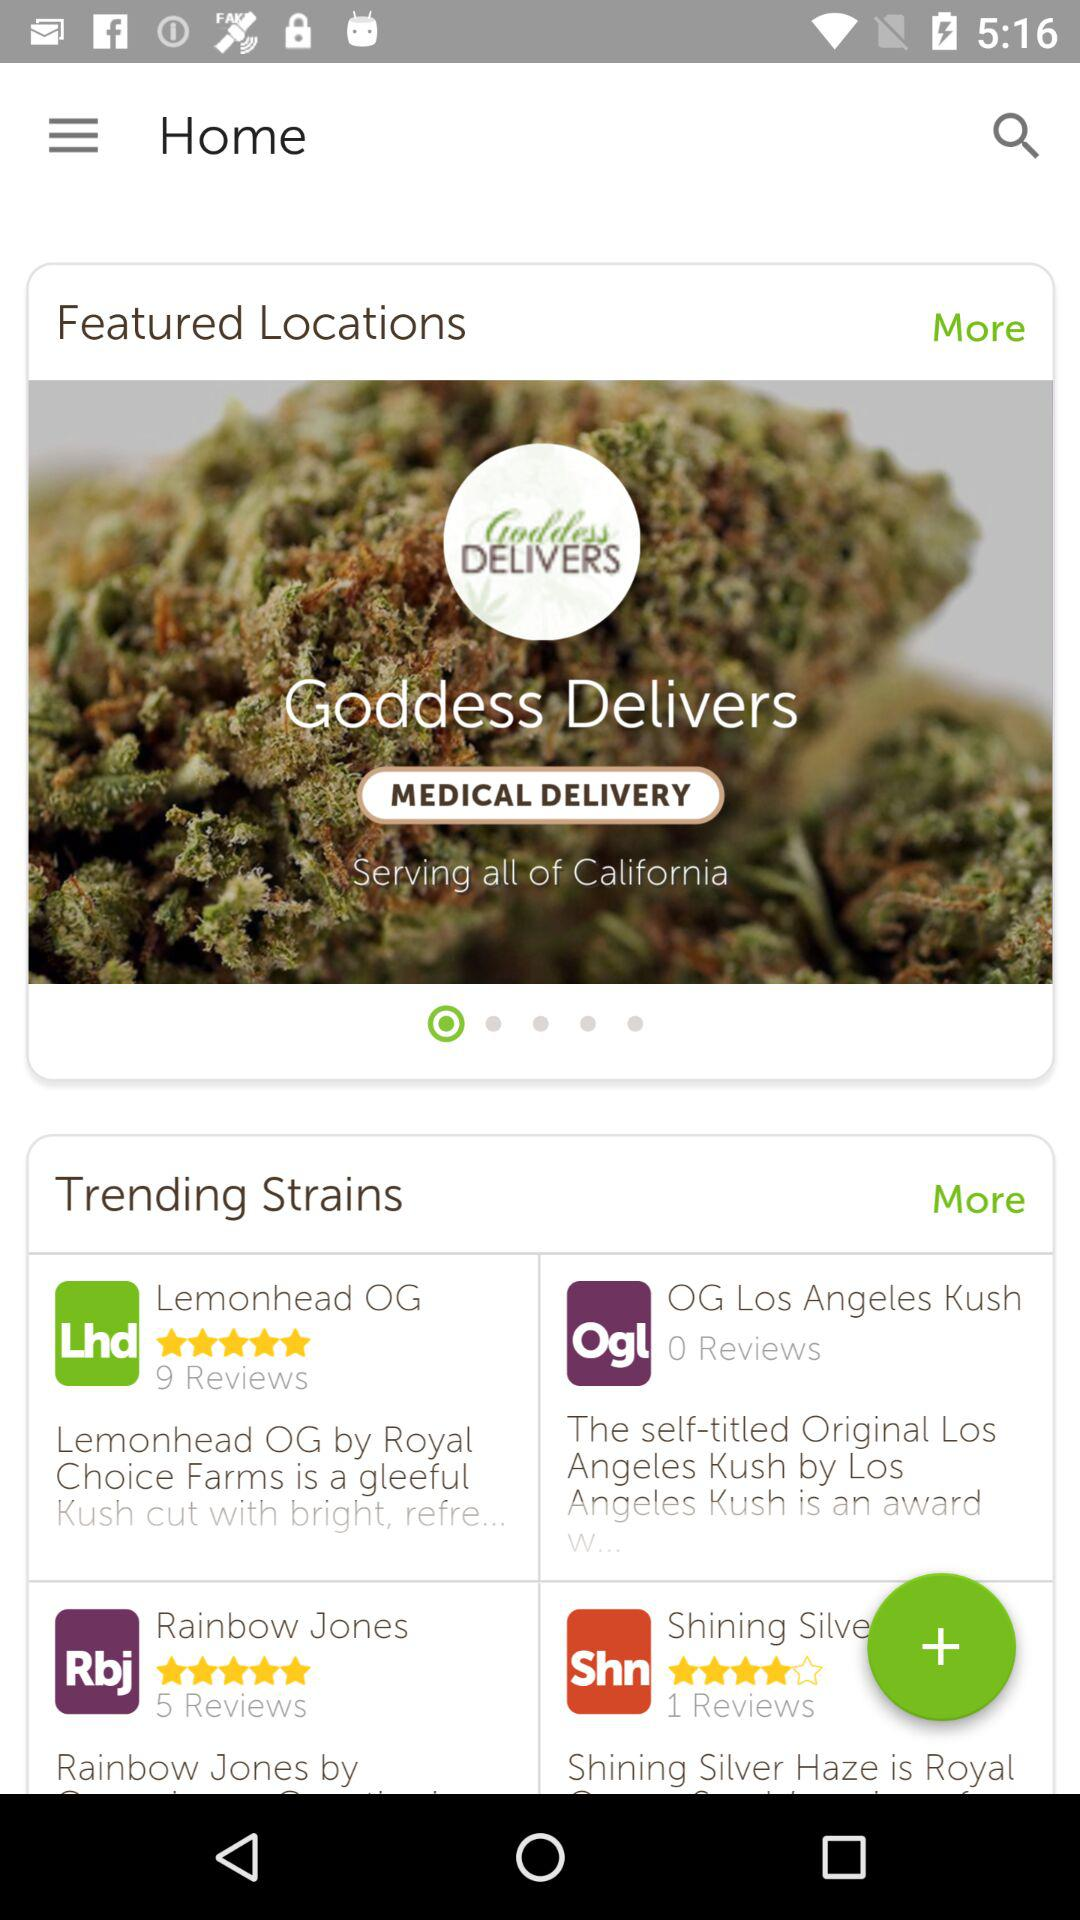What is the total number of reviewers?
When the provided information is insufficient, respond with <no answer>. <no answer> 